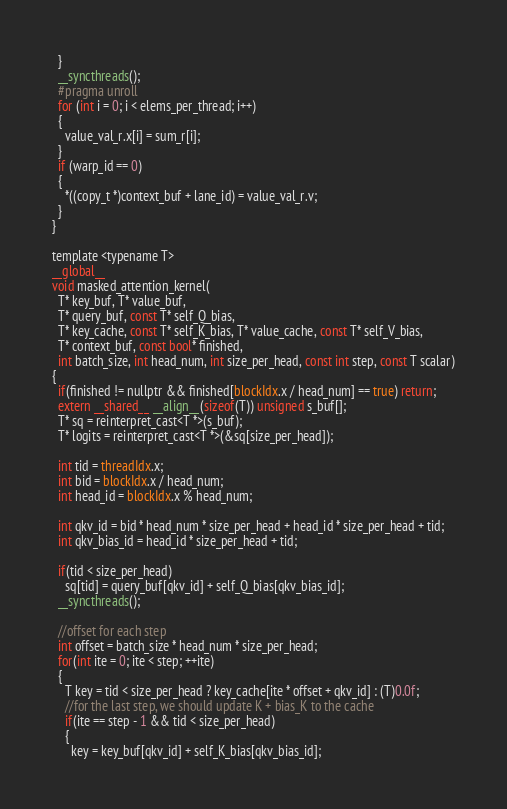Convert code to text. <code><loc_0><loc_0><loc_500><loc_500><_Cuda_>  }
  __syncthreads();
  #pragma unroll
  for (int i = 0; i < elems_per_thread; i++)
  {
    value_val_r.x[i] = sum_r[i];
  }
  if (warp_id == 0)
  {
    *((copy_t *)context_buf + lane_id) = value_val_r.v;
  }
}

template <typename T>
__global__ 
void masked_attention_kernel(
  T* key_buf, T* value_buf,
  T* query_buf, const T* self_Q_bias, 
  T* key_cache, const T* self_K_bias, T* value_cache, const T* self_V_bias,
  T* context_buf, const bool* finished,
  int batch_size, int head_num, int size_per_head, const int step, const T scalar)
{
  if(finished != nullptr && finished[blockIdx.x / head_num] == true) return;
  extern __shared__ __align__(sizeof(T)) unsigned s_buf[];
  T* sq = reinterpret_cast<T *>(s_buf);
  T* logits = reinterpret_cast<T *>(&sq[size_per_head]);

  int tid = threadIdx.x;
  int bid = blockIdx.x / head_num;
  int head_id = blockIdx.x % head_num;

  int qkv_id = bid * head_num * size_per_head + head_id * size_per_head + tid;
  int qkv_bias_id = head_id * size_per_head + tid;

  if(tid < size_per_head)
    sq[tid] = query_buf[qkv_id] + self_Q_bias[qkv_bias_id];
  __syncthreads();

  //offset for each step
  int offset = batch_size * head_num * size_per_head;
  for(int ite = 0; ite < step; ++ite)
  {
    T key = tid < size_per_head ? key_cache[ite * offset + qkv_id] : (T)0.0f;
    //for the last step, we should update K + bias_K to the cache
    if(ite == step - 1 && tid < size_per_head)
    {
      key = key_buf[qkv_id] + self_K_bias[qkv_bias_id];</code> 